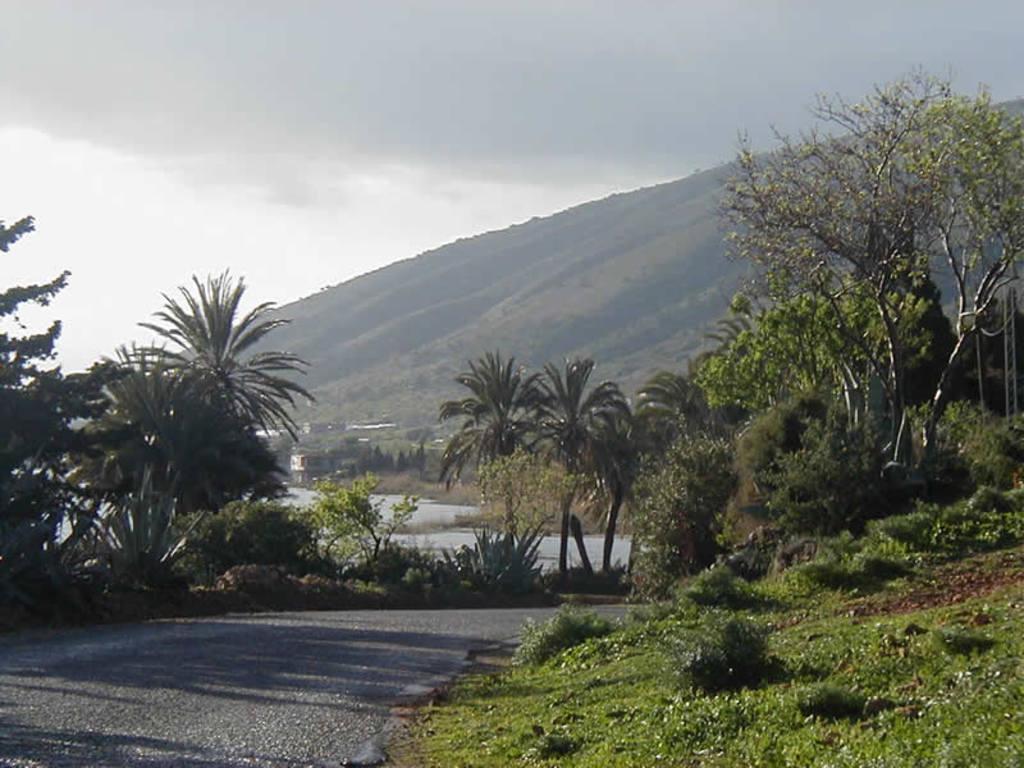Describe this image in one or two sentences. In this image we can see the mountains, one road, so many trees, plants, bushes, grass and one building. At the top there is the sky. 